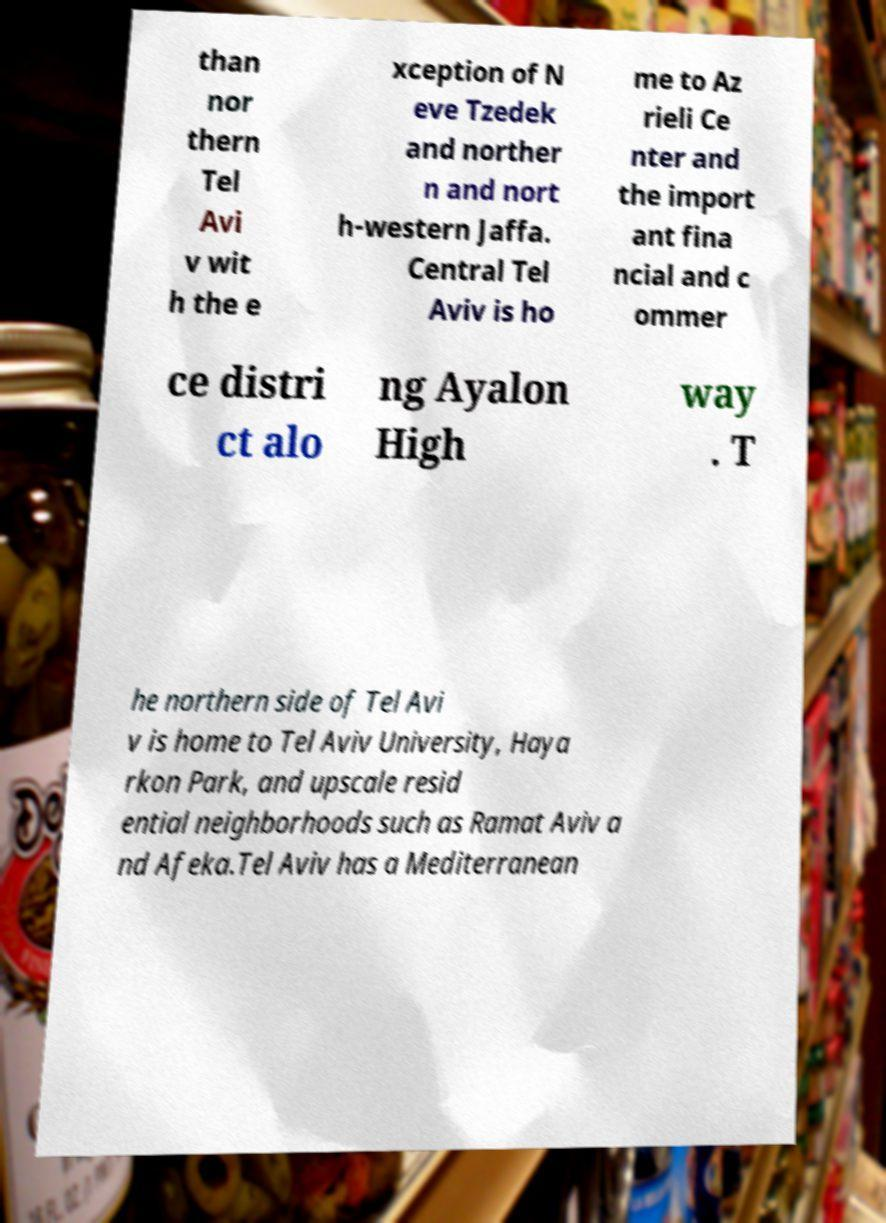Please identify and transcribe the text found in this image. than nor thern Tel Avi v wit h the e xception of N eve Tzedek and norther n and nort h-western Jaffa. Central Tel Aviv is ho me to Az rieli Ce nter and the import ant fina ncial and c ommer ce distri ct alo ng Ayalon High way . T he northern side of Tel Avi v is home to Tel Aviv University, Haya rkon Park, and upscale resid ential neighborhoods such as Ramat Aviv a nd Afeka.Tel Aviv has a Mediterranean 